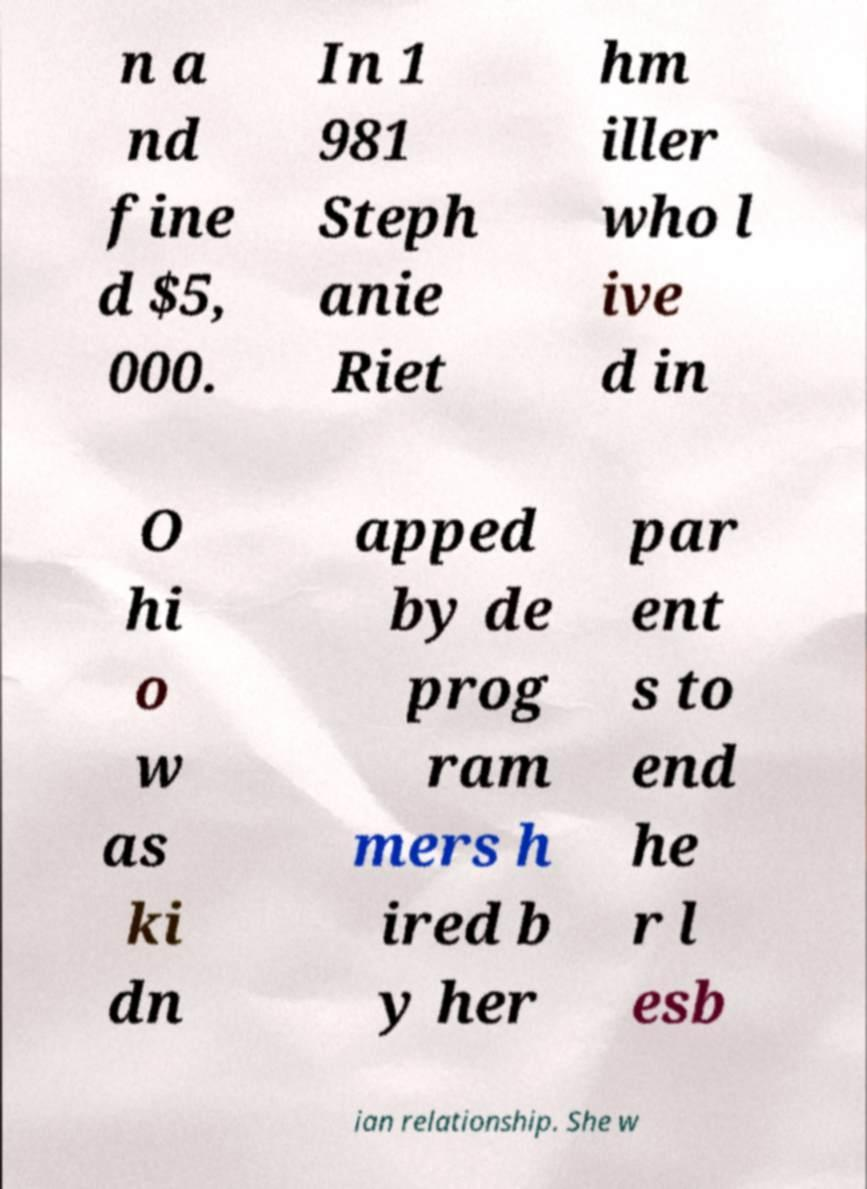What messages or text are displayed in this image? I need them in a readable, typed format. n a nd fine d $5, 000. In 1 981 Steph anie Riet hm iller who l ive d in O hi o w as ki dn apped by de prog ram mers h ired b y her par ent s to end he r l esb ian relationship. She w 